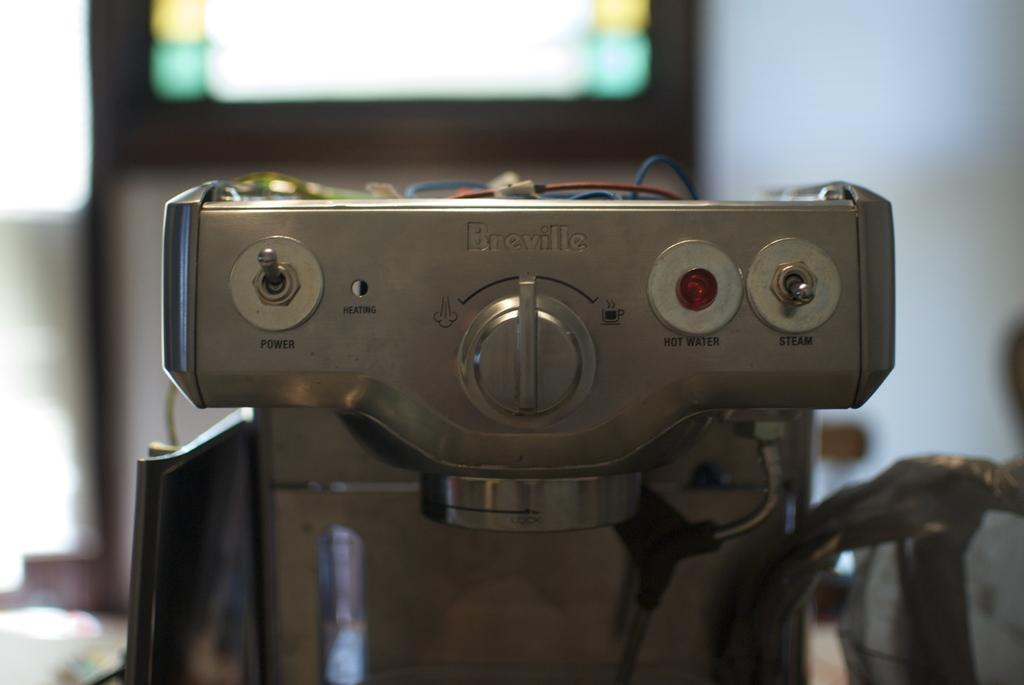What appliance is the main subject of the image? There is a coffee machine in the image. What features can be seen on the coffee machine? The coffee machine has knobs and wires on top of it. Can you describe the background of the image? The backdrop of the image is blurred. What type of nation is depicted on the dock in the image? There is no dock or nation present in the image; it features a coffee machine with knobs and wires on top, and a blurred background. How many wires are connected to the coffee machine in the image? The number of wires connected to the coffee machine cannot be determined from the image. 